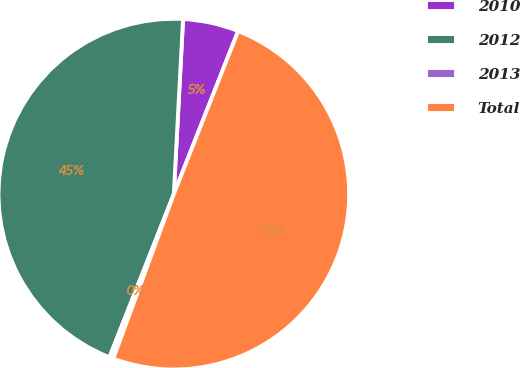Convert chart. <chart><loc_0><loc_0><loc_500><loc_500><pie_chart><fcel>2010<fcel>2012<fcel>2013<fcel>Total<nl><fcel>5.14%<fcel>44.86%<fcel>0.37%<fcel>49.63%<nl></chart> 